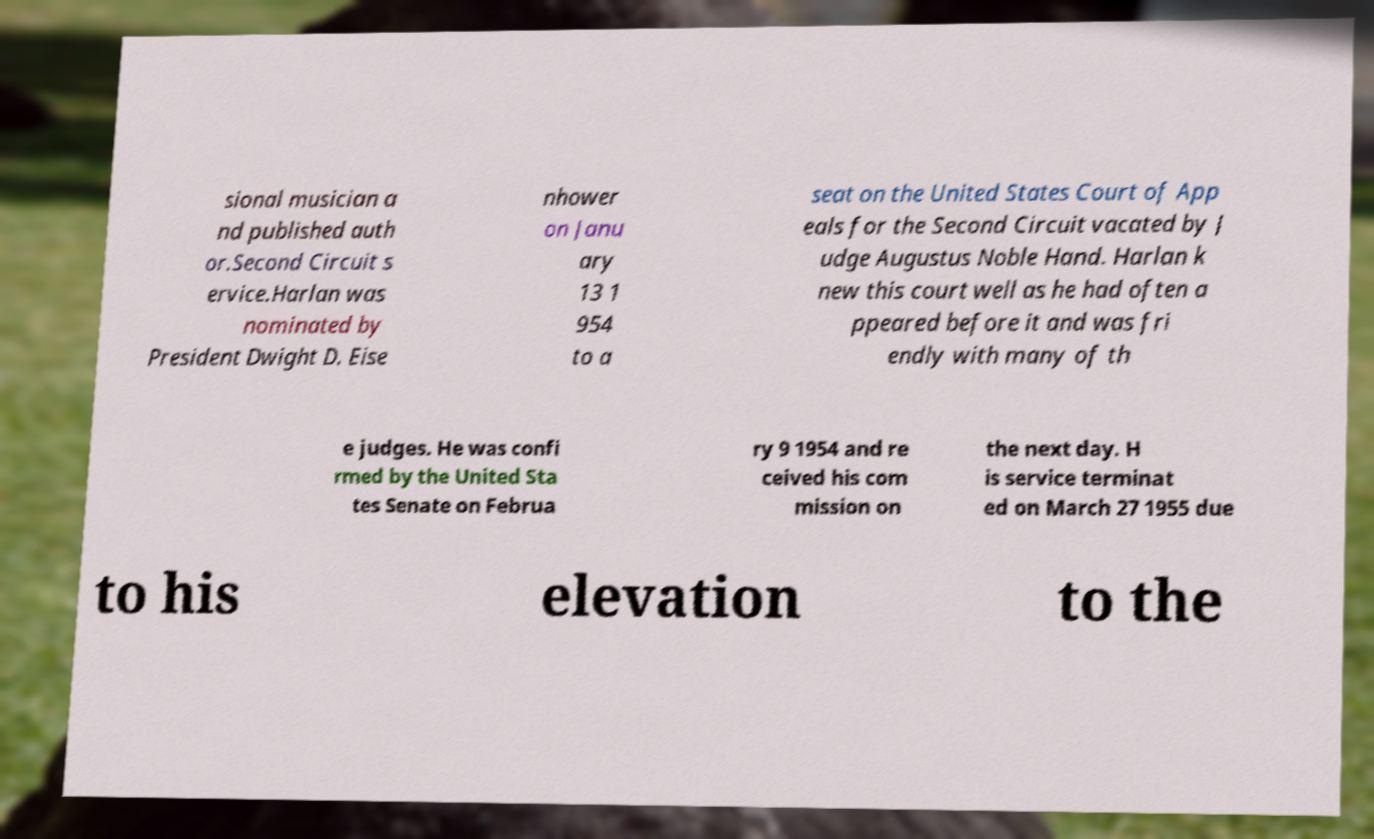Please read and relay the text visible in this image. What does it say? sional musician a nd published auth or.Second Circuit s ervice.Harlan was nominated by President Dwight D. Eise nhower on Janu ary 13 1 954 to a seat on the United States Court of App eals for the Second Circuit vacated by J udge Augustus Noble Hand. Harlan k new this court well as he had often a ppeared before it and was fri endly with many of th e judges. He was confi rmed by the United Sta tes Senate on Februa ry 9 1954 and re ceived his com mission on the next day. H is service terminat ed on March 27 1955 due to his elevation to the 